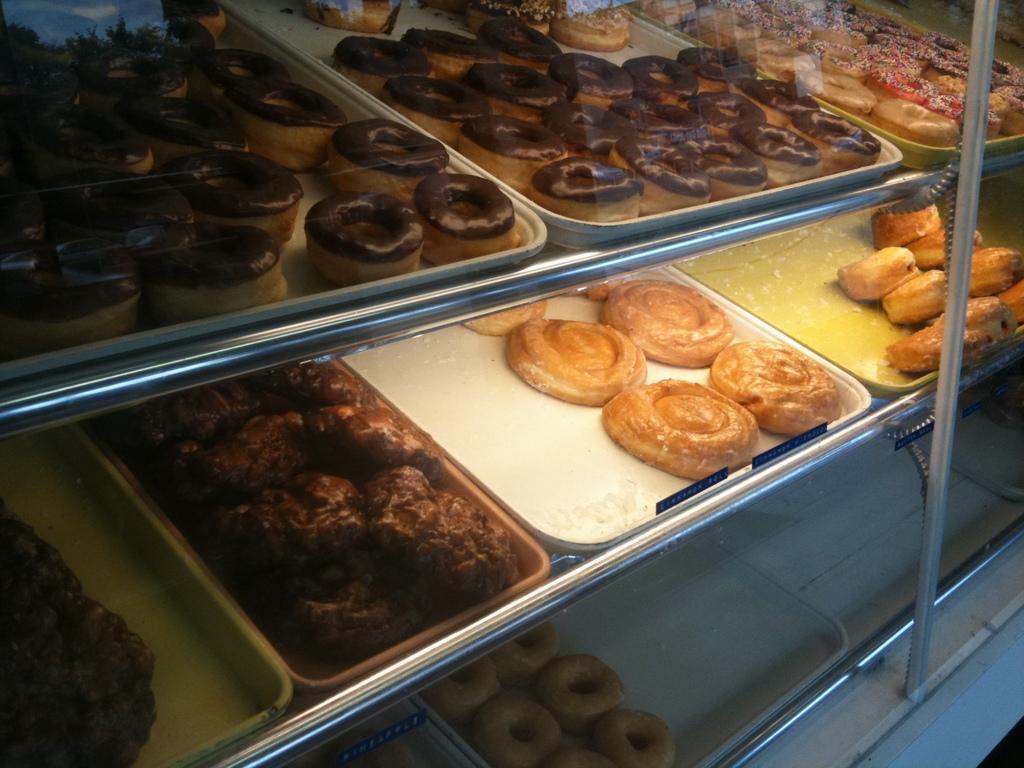Can you describe this image briefly? In this image we can see group of donuts and some food items are placed on trays kept on the racks. To the right side, we can see a pole. 